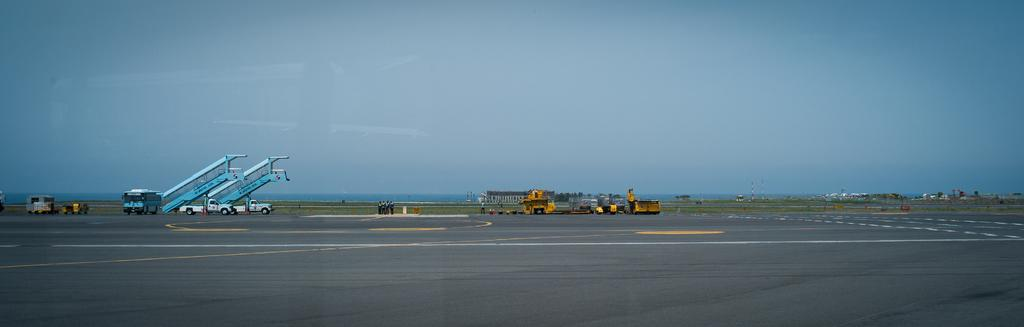Who or what can be seen in the image? There are people and vehicles in the image. What else is present in the image besides people and vehicles? There are poles, trees, objects on the road, and the sky is blue in the image. Can you describe the objects on the road? The objects on the road are not specified, but they are visible in the image. What type of hill can be seen in the image? There is no hill present in the image. How does the behavior of the people in the image affect the traffic? The behavior of the people in the image is not described, so it cannot be determined how it affects the traffic. 